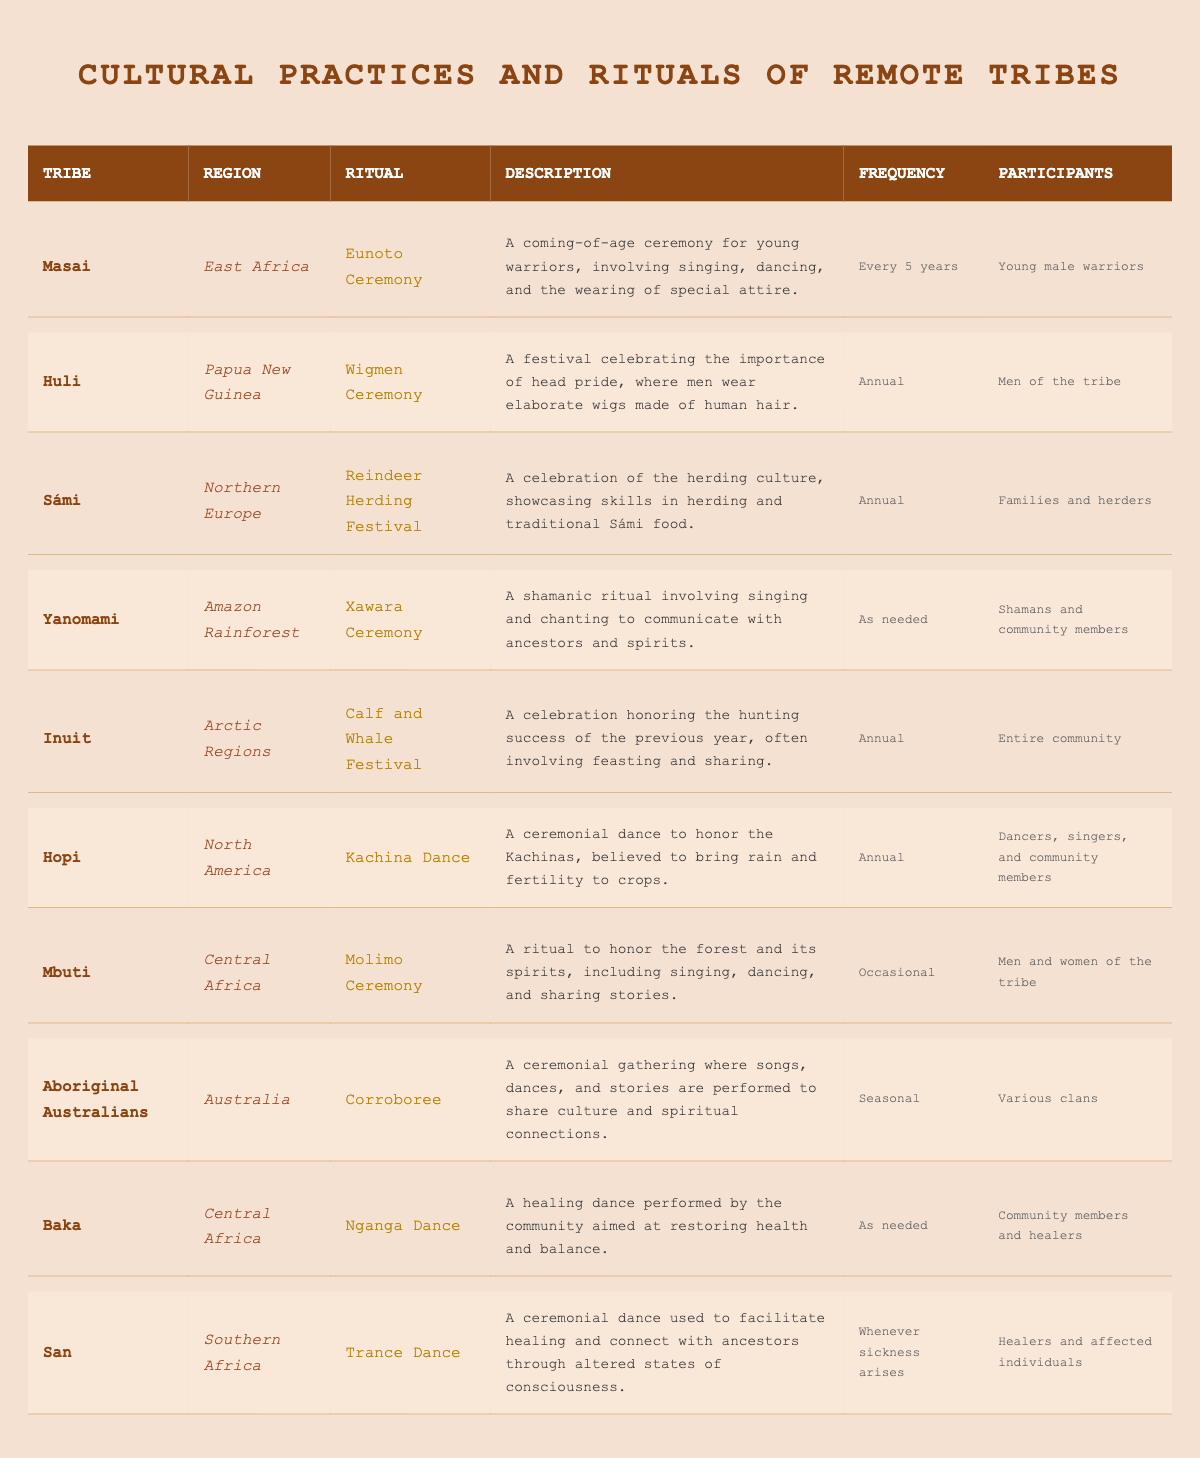What is the ritual performed by the Inuit tribe? According to the table, the ritual performed by the Inuit tribe is the "Calf and Whale Festival."
Answer: Calf and Whale Festival How often do the Sámi celebrate the Reindeer Herding Festival? The table states that the Sámi celebrate the Reindeer Herding Festival annually.
Answer: Annual Which tribe has a ritual called the "Trance Dance"? Referring to the table, the tribe with the ritual called the "Trance Dance" is the San.
Answer: San Is the Molimo Ceremony performed occasionally? The table clearly indicates that the Molimo Ceremony is listed under the frequency "Occasional," confirming that this statement is true.
Answer: Yes Which ritual involves shamans and community members? The table shows that the "Xawara Ceremony" involves shamans and community members.
Answer: Xawara Ceremony How many tribes perform their rituals annually from the table? There are four tribes listed as performing their rituals annually: Huli, Sámi, Inuit, and Hopi. Counting them gives a total of 4 tribes.
Answer: 4 What is the description of the Nganga Dance? Looking at the table, the description of the Nganga Dance is "A healing dance performed by the community aimed at restoring health and balance."
Answer: A healing dance aimed at restoring health List all the participants involved in the Eunoto Ceremony. According to the table, the participants involved in the Eunoto Ceremony are "Young male warriors."
Answer: Young male warriors Which region do the Baka tribes belong to? By checking the region column in the table, it is evident that the Baka tribes belong to Central Africa.
Answer: Central Africa What is the festival's frequency for the Wigmen Ceremony? The table specifies that the Wigmen Ceremony is celebrated annually.
Answer: Annual How does the frequency of the Corroboree differ from the Nganga Dance? The table lists the Corroboree as seasonal and the Nganga Dance as performed as needed. This shows that the Corroboree occurs at set intervals, while the Nganga Dance happens based on community needs.
Answer: Corroboree is seasonal; Nganga Dance is as needed Which tribe’s ritual is characterized by the use of elaborate wigs? From the information in the table, the Huli tribe's ritual is characterized by the use of elaborate wigs during the Wigmen Ceremony.
Answer: Huli tribe What cultural practice occurs when sickness arises, according to the table? The table states that the "Trance Dance" is performed whenever sickness arises, indicating a connection between the ritual and health within the community.
Answer: Trance Dance How many annual rituals are specifically described for the tribes listed? The five tribes listed as having annual rituals are Huli, Sámi, Inuit, Hopi, and San, making a total of 5 tribes with annual rituals.
Answer: 5 Does the Xawara Ceremony occur frequently or as needed? Looking at the table, it is indicated that the Xawara Ceremony occurs "As needed," confirming that it does not have a regular frequency.
Answer: As needed 